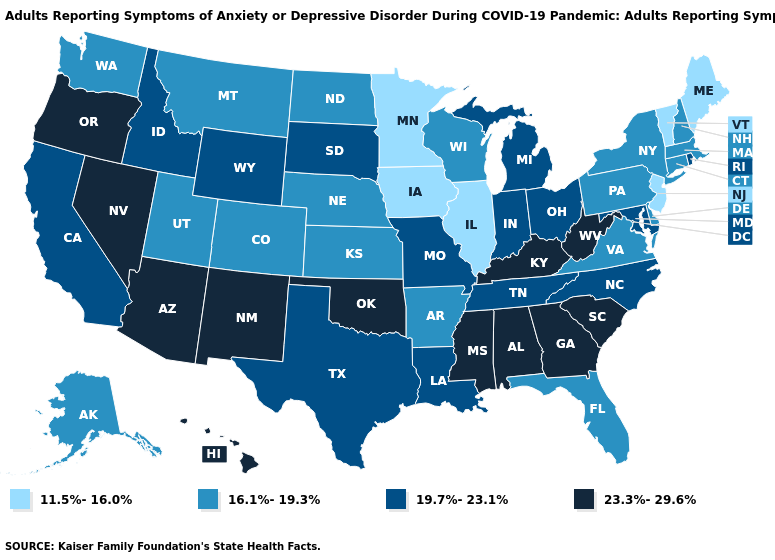Is the legend a continuous bar?
Give a very brief answer. No. Does the map have missing data?
Be succinct. No. What is the value of Maryland?
Give a very brief answer. 19.7%-23.1%. What is the highest value in the USA?
Write a very short answer. 23.3%-29.6%. Among the states that border Alabama , does Mississippi have the lowest value?
Concise answer only. No. Name the states that have a value in the range 11.5%-16.0%?
Write a very short answer. Illinois, Iowa, Maine, Minnesota, New Jersey, Vermont. What is the lowest value in the South?
Write a very short answer. 16.1%-19.3%. What is the lowest value in the USA?
Give a very brief answer. 11.5%-16.0%. Among the states that border Michigan , which have the highest value?
Answer briefly. Indiana, Ohio. What is the value of Wyoming?
Answer briefly. 19.7%-23.1%. Among the states that border Georgia , does Florida have the lowest value?
Keep it brief. Yes. Does Virginia have the same value as Vermont?
Be succinct. No. Name the states that have a value in the range 19.7%-23.1%?
Quick response, please. California, Idaho, Indiana, Louisiana, Maryland, Michigan, Missouri, North Carolina, Ohio, Rhode Island, South Dakota, Tennessee, Texas, Wyoming. Does Missouri have a higher value than Minnesota?
Concise answer only. Yes. Which states have the highest value in the USA?
Concise answer only. Alabama, Arizona, Georgia, Hawaii, Kentucky, Mississippi, Nevada, New Mexico, Oklahoma, Oregon, South Carolina, West Virginia. 